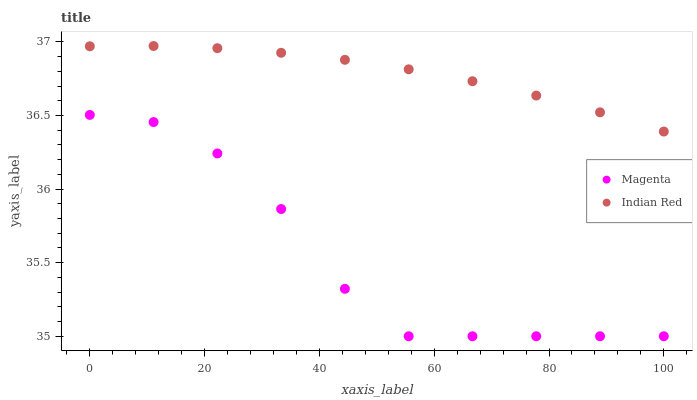Does Magenta have the minimum area under the curve?
Answer yes or no. Yes. Does Indian Red have the maximum area under the curve?
Answer yes or no. Yes. Does Indian Red have the minimum area under the curve?
Answer yes or no. No. Is Indian Red the smoothest?
Answer yes or no. Yes. Is Magenta the roughest?
Answer yes or no. Yes. Is Indian Red the roughest?
Answer yes or no. No. Does Magenta have the lowest value?
Answer yes or no. Yes. Does Indian Red have the lowest value?
Answer yes or no. No. Does Indian Red have the highest value?
Answer yes or no. Yes. Is Magenta less than Indian Red?
Answer yes or no. Yes. Is Indian Red greater than Magenta?
Answer yes or no. Yes. Does Magenta intersect Indian Red?
Answer yes or no. No. 